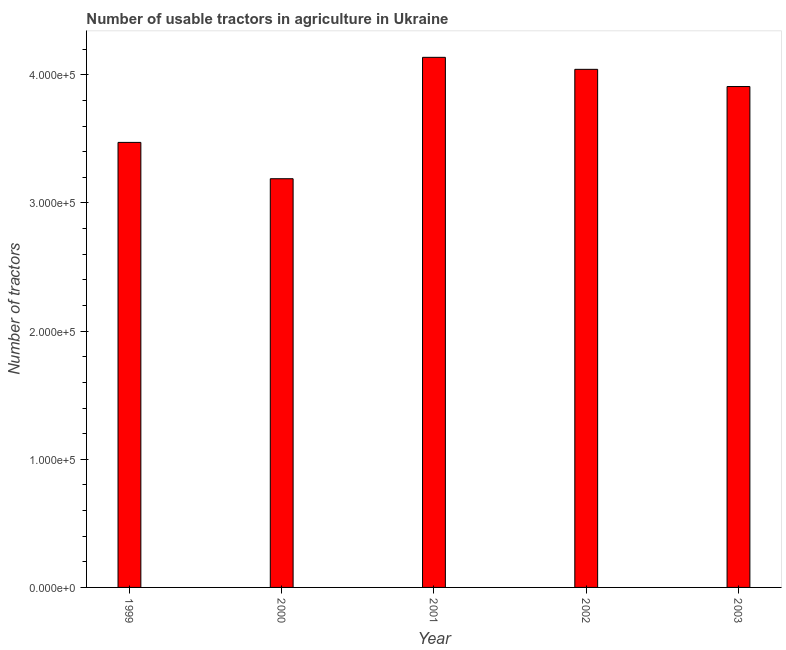Does the graph contain grids?
Provide a succinct answer. No. What is the title of the graph?
Your answer should be compact. Number of usable tractors in agriculture in Ukraine. What is the label or title of the X-axis?
Offer a very short reply. Year. What is the label or title of the Y-axis?
Your answer should be very brief. Number of tractors. What is the number of tractors in 2000?
Ensure brevity in your answer.  3.19e+05. Across all years, what is the maximum number of tractors?
Give a very brief answer. 4.14e+05. Across all years, what is the minimum number of tractors?
Make the answer very short. 3.19e+05. In which year was the number of tractors minimum?
Keep it short and to the point. 2000. What is the sum of the number of tractors?
Ensure brevity in your answer.  1.87e+06. What is the difference between the number of tractors in 2000 and 2001?
Provide a succinct answer. -9.47e+04. What is the average number of tractors per year?
Ensure brevity in your answer.  3.75e+05. What is the median number of tractors?
Offer a terse response. 3.91e+05. Do a majority of the years between 2003 and 2001 (inclusive) have number of tractors greater than 20000 ?
Provide a short and direct response. Yes. What is the ratio of the number of tractors in 2000 to that in 2003?
Provide a short and direct response. 0.82. What is the difference between the highest and the second highest number of tractors?
Offer a terse response. 9366. What is the difference between the highest and the lowest number of tractors?
Provide a succinct answer. 9.47e+04. In how many years, is the number of tractors greater than the average number of tractors taken over all years?
Keep it short and to the point. 3. How many bars are there?
Your answer should be compact. 5. Are all the bars in the graph horizontal?
Offer a very short reply. No. How many years are there in the graph?
Provide a short and direct response. 5. What is the difference between two consecutive major ticks on the Y-axis?
Your response must be concise. 1.00e+05. Are the values on the major ticks of Y-axis written in scientific E-notation?
Your answer should be very brief. Yes. What is the Number of tractors of 1999?
Offer a terse response. 3.47e+05. What is the Number of tractors of 2000?
Offer a terse response. 3.19e+05. What is the Number of tractors in 2001?
Ensure brevity in your answer.  4.14e+05. What is the Number of tractors in 2002?
Offer a very short reply. 4.04e+05. What is the Number of tractors of 2003?
Offer a terse response. 3.91e+05. What is the difference between the Number of tractors in 1999 and 2000?
Offer a terse response. 2.83e+04. What is the difference between the Number of tractors in 1999 and 2001?
Your answer should be very brief. -6.64e+04. What is the difference between the Number of tractors in 1999 and 2002?
Your response must be concise. -5.70e+04. What is the difference between the Number of tractors in 1999 and 2003?
Your answer should be compact. -4.36e+04. What is the difference between the Number of tractors in 2000 and 2001?
Ensure brevity in your answer.  -9.47e+04. What is the difference between the Number of tractors in 2000 and 2002?
Your response must be concise. -8.54e+04. What is the difference between the Number of tractors in 2000 and 2003?
Provide a succinct answer. -7.19e+04. What is the difference between the Number of tractors in 2001 and 2002?
Provide a short and direct response. 9366. What is the difference between the Number of tractors in 2001 and 2003?
Offer a very short reply. 2.28e+04. What is the difference between the Number of tractors in 2002 and 2003?
Your answer should be compact. 1.34e+04. What is the ratio of the Number of tractors in 1999 to that in 2000?
Provide a succinct answer. 1.09. What is the ratio of the Number of tractors in 1999 to that in 2001?
Your response must be concise. 0.84. What is the ratio of the Number of tractors in 1999 to that in 2002?
Your answer should be very brief. 0.86. What is the ratio of the Number of tractors in 1999 to that in 2003?
Offer a terse response. 0.89. What is the ratio of the Number of tractors in 2000 to that in 2001?
Your response must be concise. 0.77. What is the ratio of the Number of tractors in 2000 to that in 2002?
Provide a succinct answer. 0.79. What is the ratio of the Number of tractors in 2000 to that in 2003?
Your response must be concise. 0.82. What is the ratio of the Number of tractors in 2001 to that in 2002?
Offer a terse response. 1.02. What is the ratio of the Number of tractors in 2001 to that in 2003?
Your response must be concise. 1.06. What is the ratio of the Number of tractors in 2002 to that in 2003?
Offer a very short reply. 1.03. 